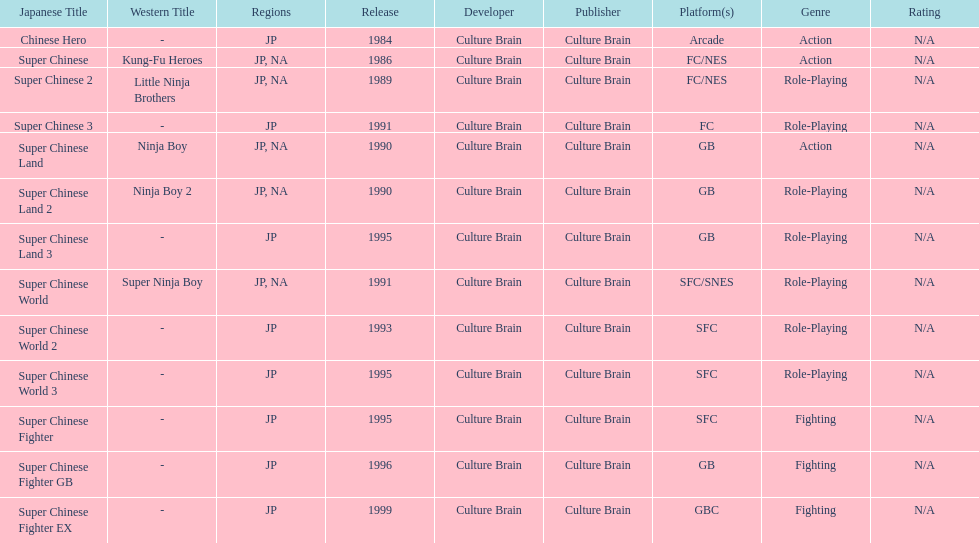Could you parse the entire table as a dict? {'header': ['Japanese Title', 'Western Title', 'Regions', 'Release', 'Developer', 'Publisher', 'Platform(s)', 'Genre', 'Rating'], 'rows': [['Chinese Hero', '-', 'JP', '1984', 'Culture Brain', 'Culture Brain', 'Arcade', 'Action', 'N/A'], ['Super Chinese', 'Kung-Fu Heroes', 'JP, NA', '1986', 'Culture Brain', 'Culture Brain', 'FC/NES', 'Action', 'N/A'], ['Super Chinese 2', 'Little Ninja Brothers', 'JP, NA', '1989', 'Culture Brain', 'Culture Brain', 'FC/NES', 'Role-Playing', 'N/A'], ['Super Chinese 3', '-', 'JP', '1991', 'Culture Brain', 'Culture Brain', 'FC', 'Role-Playing', 'N/A'], ['Super Chinese Land', 'Ninja Boy', 'JP, NA', '1990', 'Culture Brain', 'Culture Brain', 'GB', 'Action', 'N/A'], ['Super Chinese Land 2', 'Ninja Boy 2', 'JP, NA', '1990', 'Culture Brain', 'Culture Brain', 'GB', 'Role-Playing', 'N/A'], ['Super Chinese Land 3', '-', 'JP', '1995', 'Culture Brain', 'Culture Brain', 'GB', 'Role-Playing', 'N/A'], ['Super Chinese World', 'Super Ninja Boy', 'JP, NA', '1991', 'Culture Brain', 'Culture Brain', 'SFC/SNES', 'Role-Playing', 'N/A'], ['Super Chinese World 2', '-', 'JP', '1993', 'Culture Brain', 'Culture Brain', 'SFC', 'Role-Playing', 'N/A'], ['Super Chinese World 3', '-', 'JP', '1995', 'Culture Brain', 'Culture Brain', 'SFC', 'Role-Playing', 'N/A'], ['Super Chinese Fighter', '-', 'JP', '1995', 'Culture Brain', 'Culture Brain', 'SFC', 'Fighting', 'N/A'], ['Super Chinese Fighter GB', '-', 'JP', '1996', 'Culture Brain', 'Culture Brain', 'GB', 'Fighting', 'N/A'], ['Super Chinese Fighter EX', '-', 'JP', '1999', 'Culture Brain', 'Culture Brain', 'GBC', 'Fighting', 'N/A']]} What are the total of super chinese games released? 13. 